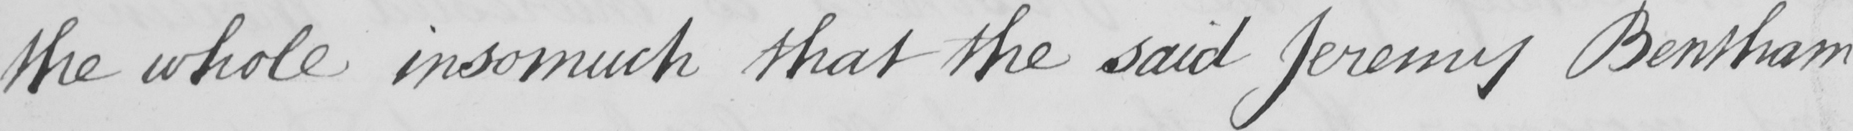Can you tell me what this handwritten text says? the whole insomuch that the said Jeremy Bentham 